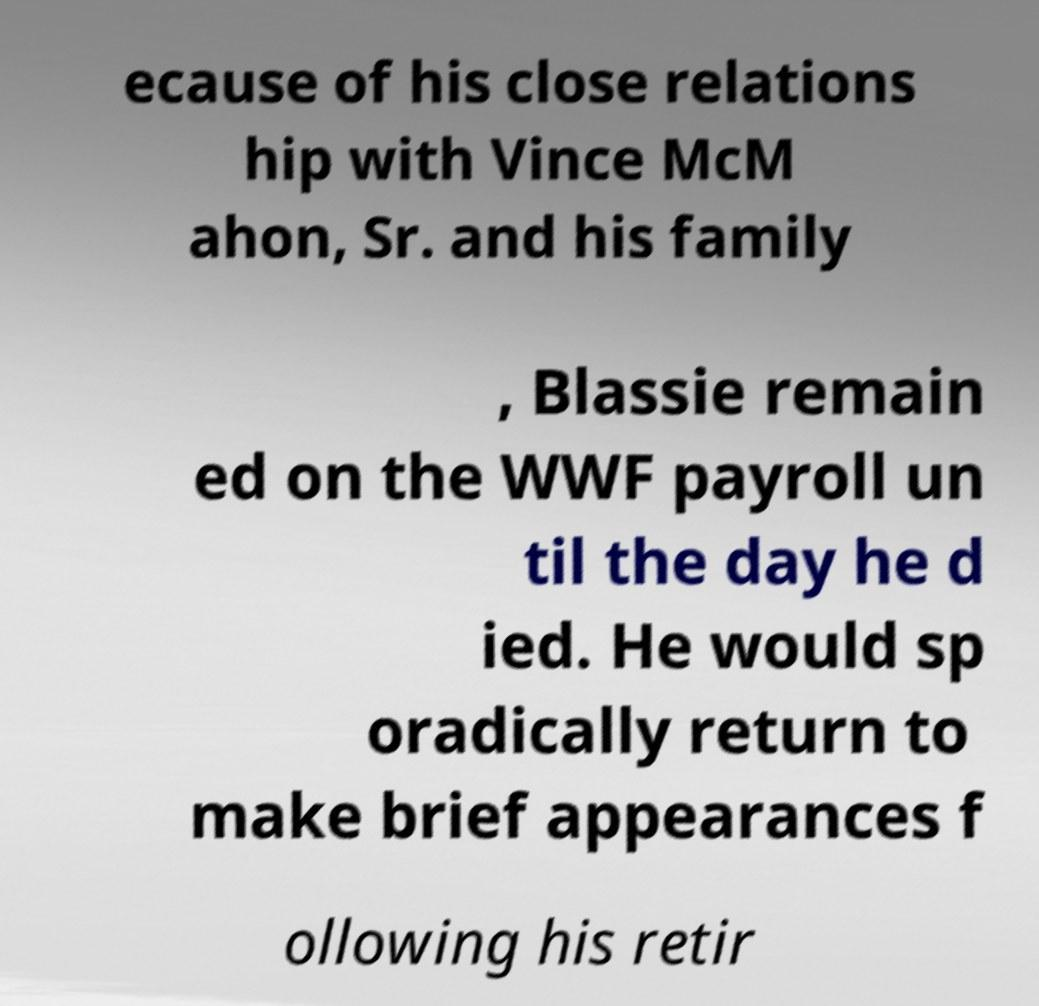Can you accurately transcribe the text from the provided image for me? ecause of his close relations hip with Vince McM ahon, Sr. and his family , Blassie remain ed on the WWF payroll un til the day he d ied. He would sp oradically return to make brief appearances f ollowing his retir 